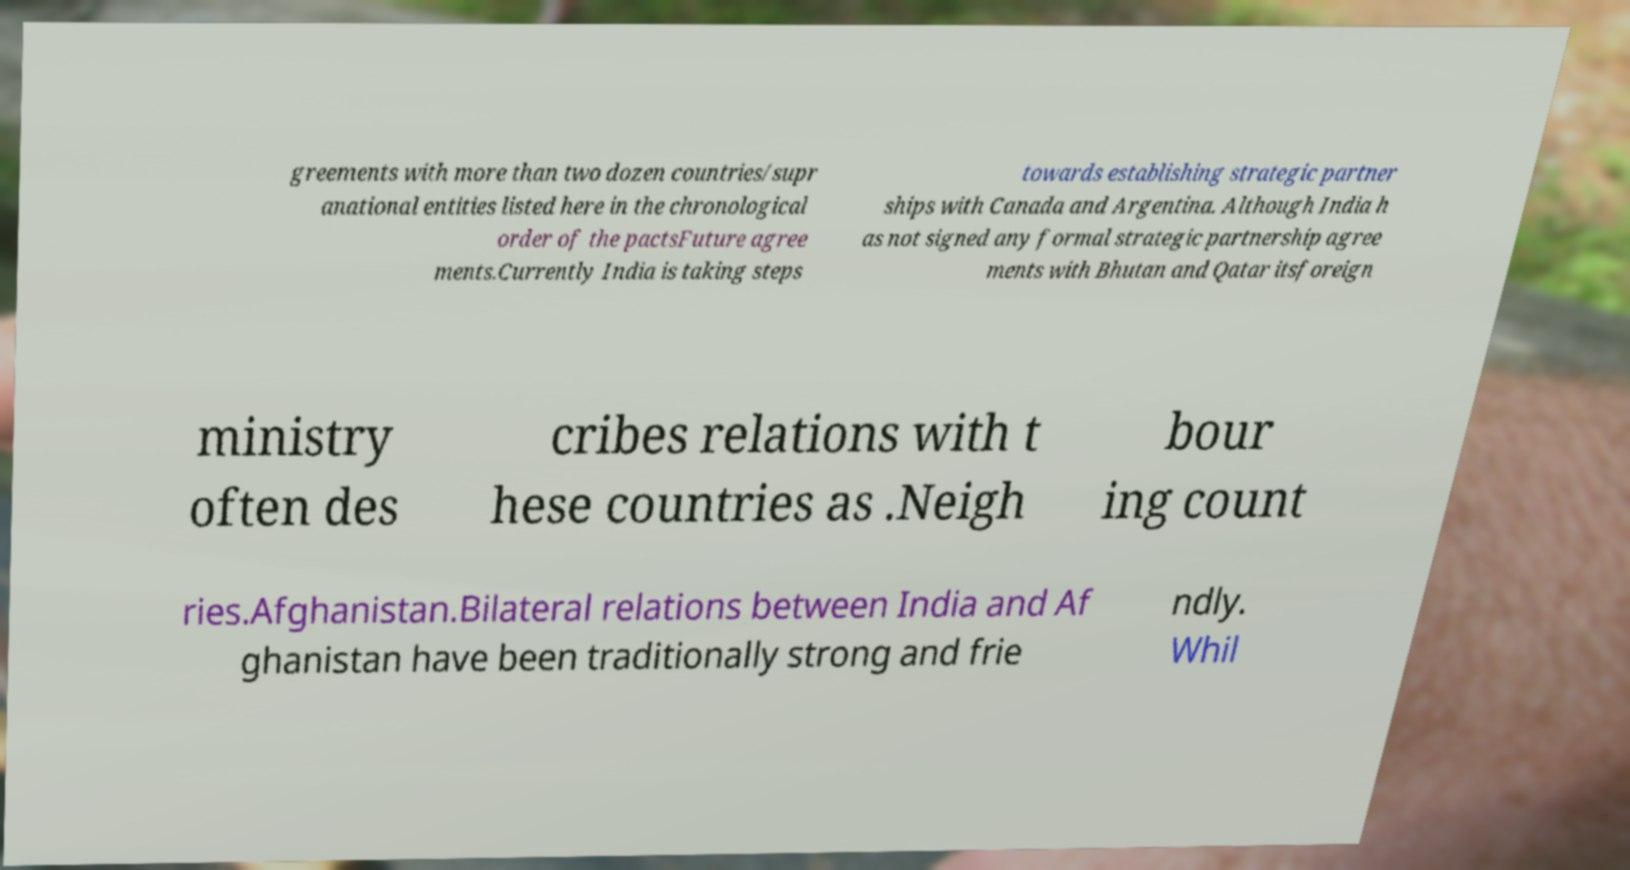Please identify and transcribe the text found in this image. greements with more than two dozen countries/supr anational entities listed here in the chronological order of the pactsFuture agree ments.Currently India is taking steps towards establishing strategic partner ships with Canada and Argentina. Although India h as not signed any formal strategic partnership agree ments with Bhutan and Qatar itsforeign ministry often des cribes relations with t hese countries as .Neigh bour ing count ries.Afghanistan.Bilateral relations between India and Af ghanistan have been traditionally strong and frie ndly. Whil 